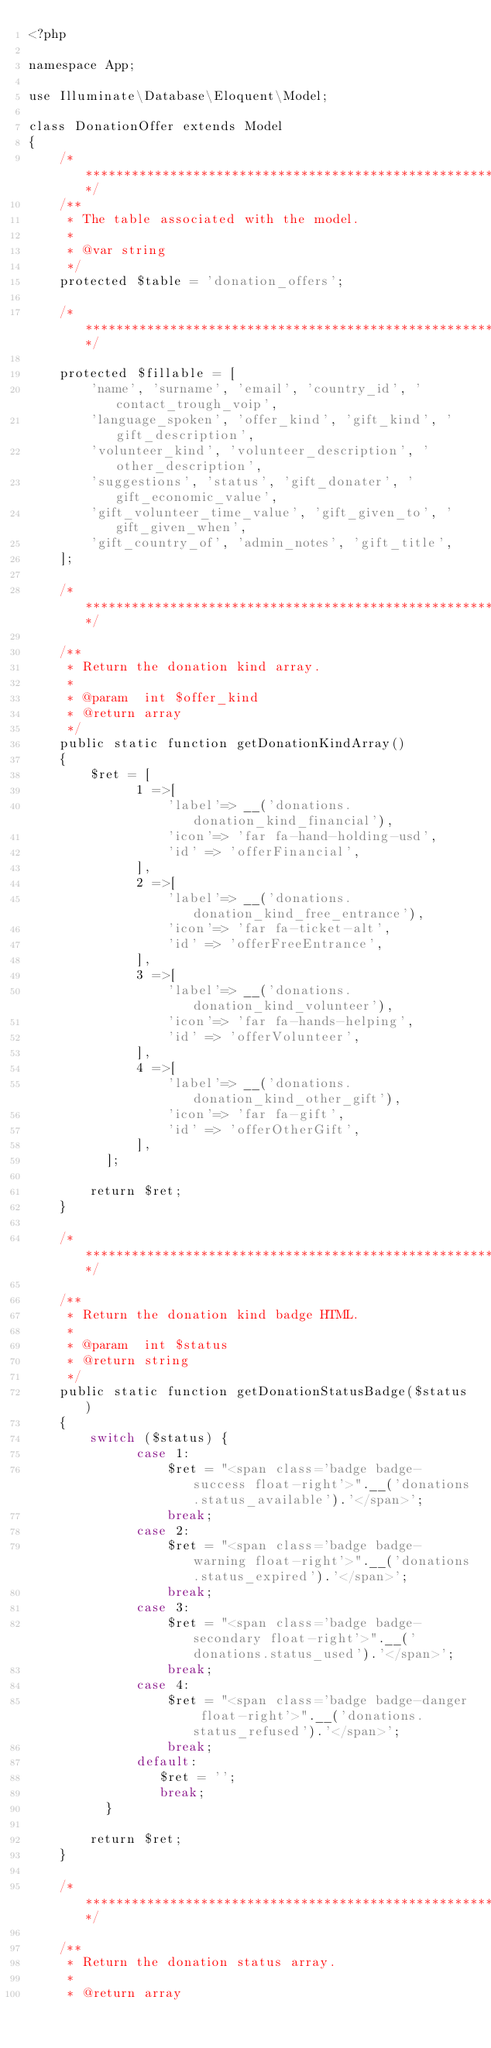Convert code to text. <code><loc_0><loc_0><loc_500><loc_500><_PHP_><?php

namespace App;

use Illuminate\Database\Eloquent\Model;

class DonationOffer extends Model
{
    /***************************************************************************/
    /**
     * The table associated with the model.
     *
     * @var string
     */
    protected $table = 'donation_offers';

    /***************************************************************************/

    protected $fillable = [
        'name', 'surname', 'email', 'country_id', 'contact_trough_voip',
        'language_spoken', 'offer_kind', 'gift_kind', 'gift_description',
        'volunteer_kind', 'volunteer_description', 'other_description',
        'suggestions', 'status', 'gift_donater', 'gift_economic_value',
        'gift_volunteer_time_value', 'gift_given_to', 'gift_given_when',
        'gift_country_of', 'admin_notes', 'gift_title',
    ];

    /***************************************************************************/

    /**
     * Return the donation kind array.
     *
     * @param  int $offer_kind
     * @return array
     */
    public static function getDonationKindArray()
    {
        $ret = [
              1 =>[
                  'label'=> __('donations.donation_kind_financial'),
                  'icon'=> 'far fa-hand-holding-usd',
                  'id' => 'offerFinancial',
              ],
              2 =>[
                  'label'=> __('donations.donation_kind_free_entrance'),
                  'icon'=> 'far fa-ticket-alt',
                  'id' => 'offerFreeEntrance',
              ],
              3 =>[
                  'label'=> __('donations.donation_kind_volunteer'),
                  'icon'=> 'far fa-hands-helping',
                  'id' => 'offerVolunteer',
              ],
              4 =>[
                  'label'=> __('donations.donation_kind_other_gift'),
                  'icon'=> 'far fa-gift',
                  'id' => 'offerOtherGift',
              ],
          ];

        return $ret;
    }

    /***************************************************************************/

    /**
     * Return the donation kind badge HTML.
     *
     * @param  int $status
     * @return string
     */
    public static function getDonationStatusBadge($status)
    {
        switch ($status) {
              case 1:
                  $ret = "<span class='badge badge-success float-right'>".__('donations.status_available').'</span>';
                  break;
              case 2:
                  $ret = "<span class='badge badge-warning float-right'>".__('donations.status_expired').'</span>';
                  break;
              case 3:
                  $ret = "<span class='badge badge-secondary float-right'>".__('donations.status_used').'</span>';
                  break;
              case 4:
                  $ret = "<span class='badge badge-danger float-right'>".__('donations.status_refused').'</span>';
                  break;
              default:
                 $ret = '';
                 break;
          }

        return $ret;
    }

    /***************************************************************************/

    /**
     * Return the donation status array.
     *
     * @return array</code> 